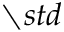Convert formula to latex. <formula><loc_0><loc_0><loc_500><loc_500>\ s t d</formula> 